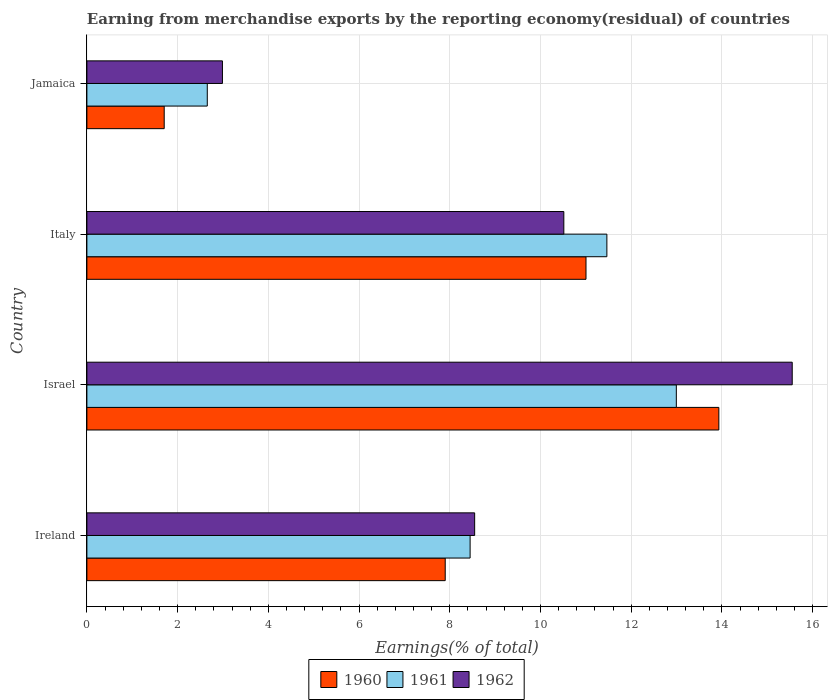How many groups of bars are there?
Offer a very short reply. 4. Are the number of bars on each tick of the Y-axis equal?
Offer a very short reply. Yes. How many bars are there on the 1st tick from the top?
Offer a very short reply. 3. What is the label of the 2nd group of bars from the top?
Your answer should be compact. Italy. What is the percentage of amount earned from merchandise exports in 1960 in Jamaica?
Offer a terse response. 1.7. Across all countries, what is the maximum percentage of amount earned from merchandise exports in 1960?
Your answer should be very brief. 13.93. Across all countries, what is the minimum percentage of amount earned from merchandise exports in 1962?
Ensure brevity in your answer.  2.99. In which country was the percentage of amount earned from merchandise exports in 1962 maximum?
Ensure brevity in your answer.  Israel. In which country was the percentage of amount earned from merchandise exports in 1962 minimum?
Your answer should be compact. Jamaica. What is the total percentage of amount earned from merchandise exports in 1960 in the graph?
Provide a succinct answer. 34.54. What is the difference between the percentage of amount earned from merchandise exports in 1960 in Ireland and that in Jamaica?
Offer a terse response. 6.2. What is the difference between the percentage of amount earned from merchandise exports in 1960 in Israel and the percentage of amount earned from merchandise exports in 1961 in Italy?
Ensure brevity in your answer.  2.47. What is the average percentage of amount earned from merchandise exports in 1962 per country?
Provide a short and direct response. 9.4. What is the difference between the percentage of amount earned from merchandise exports in 1962 and percentage of amount earned from merchandise exports in 1961 in Ireland?
Provide a succinct answer. 0.1. In how many countries, is the percentage of amount earned from merchandise exports in 1962 greater than 11.2 %?
Your response must be concise. 1. What is the ratio of the percentage of amount earned from merchandise exports in 1962 in Ireland to that in Israel?
Ensure brevity in your answer.  0.55. Is the percentage of amount earned from merchandise exports in 1961 in Ireland less than that in Italy?
Provide a succinct answer. Yes. Is the difference between the percentage of amount earned from merchandise exports in 1962 in Ireland and Italy greater than the difference between the percentage of amount earned from merchandise exports in 1961 in Ireland and Italy?
Offer a terse response. Yes. What is the difference between the highest and the second highest percentage of amount earned from merchandise exports in 1962?
Provide a short and direct response. 5.04. What is the difference between the highest and the lowest percentage of amount earned from merchandise exports in 1961?
Keep it short and to the point. 10.34. What does the 1st bar from the bottom in Italy represents?
Make the answer very short. 1960. Is it the case that in every country, the sum of the percentage of amount earned from merchandise exports in 1960 and percentage of amount earned from merchandise exports in 1961 is greater than the percentage of amount earned from merchandise exports in 1962?
Your response must be concise. Yes. How many bars are there?
Ensure brevity in your answer.  12. Are the values on the major ticks of X-axis written in scientific E-notation?
Make the answer very short. No. Does the graph contain any zero values?
Provide a short and direct response. No. Does the graph contain grids?
Your response must be concise. Yes. Where does the legend appear in the graph?
Give a very brief answer. Bottom center. How are the legend labels stacked?
Make the answer very short. Horizontal. What is the title of the graph?
Offer a terse response. Earning from merchandise exports by the reporting economy(residual) of countries. Does "2010" appear as one of the legend labels in the graph?
Keep it short and to the point. No. What is the label or title of the X-axis?
Your answer should be very brief. Earnings(% of total). What is the Earnings(% of total) of 1960 in Ireland?
Keep it short and to the point. 7.9. What is the Earnings(% of total) in 1961 in Ireland?
Keep it short and to the point. 8.45. What is the Earnings(% of total) of 1962 in Ireland?
Make the answer very short. 8.55. What is the Earnings(% of total) in 1960 in Israel?
Offer a very short reply. 13.93. What is the Earnings(% of total) in 1961 in Israel?
Ensure brevity in your answer.  13. What is the Earnings(% of total) in 1962 in Israel?
Ensure brevity in your answer.  15.55. What is the Earnings(% of total) in 1960 in Italy?
Your answer should be very brief. 11. What is the Earnings(% of total) in 1961 in Italy?
Provide a short and direct response. 11.46. What is the Earnings(% of total) of 1962 in Italy?
Give a very brief answer. 10.52. What is the Earnings(% of total) of 1960 in Jamaica?
Provide a short and direct response. 1.7. What is the Earnings(% of total) of 1961 in Jamaica?
Give a very brief answer. 2.65. What is the Earnings(% of total) of 1962 in Jamaica?
Ensure brevity in your answer.  2.99. Across all countries, what is the maximum Earnings(% of total) of 1960?
Your answer should be compact. 13.93. Across all countries, what is the maximum Earnings(% of total) of 1961?
Ensure brevity in your answer.  13. Across all countries, what is the maximum Earnings(% of total) in 1962?
Your answer should be very brief. 15.55. Across all countries, what is the minimum Earnings(% of total) of 1960?
Provide a short and direct response. 1.7. Across all countries, what is the minimum Earnings(% of total) of 1961?
Your answer should be very brief. 2.65. Across all countries, what is the minimum Earnings(% of total) in 1962?
Your response must be concise. 2.99. What is the total Earnings(% of total) of 1960 in the graph?
Provide a short and direct response. 34.54. What is the total Earnings(% of total) of 1961 in the graph?
Offer a very short reply. 35.56. What is the total Earnings(% of total) in 1962 in the graph?
Offer a terse response. 37.6. What is the difference between the Earnings(% of total) of 1960 in Ireland and that in Israel?
Your response must be concise. -6.03. What is the difference between the Earnings(% of total) in 1961 in Ireland and that in Israel?
Your response must be concise. -4.55. What is the difference between the Earnings(% of total) of 1962 in Ireland and that in Israel?
Provide a short and direct response. -7. What is the difference between the Earnings(% of total) of 1960 in Ireland and that in Italy?
Offer a terse response. -3.1. What is the difference between the Earnings(% of total) of 1961 in Ireland and that in Italy?
Make the answer very short. -3.02. What is the difference between the Earnings(% of total) in 1962 in Ireland and that in Italy?
Offer a terse response. -1.97. What is the difference between the Earnings(% of total) in 1960 in Ireland and that in Jamaica?
Your answer should be compact. 6.2. What is the difference between the Earnings(% of total) in 1961 in Ireland and that in Jamaica?
Ensure brevity in your answer.  5.79. What is the difference between the Earnings(% of total) of 1962 in Ireland and that in Jamaica?
Offer a terse response. 5.56. What is the difference between the Earnings(% of total) of 1960 in Israel and that in Italy?
Keep it short and to the point. 2.93. What is the difference between the Earnings(% of total) of 1961 in Israel and that in Italy?
Ensure brevity in your answer.  1.53. What is the difference between the Earnings(% of total) of 1962 in Israel and that in Italy?
Your response must be concise. 5.04. What is the difference between the Earnings(% of total) in 1960 in Israel and that in Jamaica?
Provide a succinct answer. 12.23. What is the difference between the Earnings(% of total) in 1961 in Israel and that in Jamaica?
Give a very brief answer. 10.34. What is the difference between the Earnings(% of total) in 1962 in Israel and that in Jamaica?
Your answer should be very brief. 12.56. What is the difference between the Earnings(% of total) in 1960 in Italy and that in Jamaica?
Keep it short and to the point. 9.3. What is the difference between the Earnings(% of total) of 1961 in Italy and that in Jamaica?
Provide a short and direct response. 8.81. What is the difference between the Earnings(% of total) in 1962 in Italy and that in Jamaica?
Keep it short and to the point. 7.53. What is the difference between the Earnings(% of total) of 1960 in Ireland and the Earnings(% of total) of 1961 in Israel?
Your answer should be very brief. -5.1. What is the difference between the Earnings(% of total) of 1960 in Ireland and the Earnings(% of total) of 1962 in Israel?
Keep it short and to the point. -7.65. What is the difference between the Earnings(% of total) in 1961 in Ireland and the Earnings(% of total) in 1962 in Israel?
Provide a short and direct response. -7.1. What is the difference between the Earnings(% of total) in 1960 in Ireland and the Earnings(% of total) in 1961 in Italy?
Your answer should be very brief. -3.56. What is the difference between the Earnings(% of total) in 1960 in Ireland and the Earnings(% of total) in 1962 in Italy?
Ensure brevity in your answer.  -2.61. What is the difference between the Earnings(% of total) of 1961 in Ireland and the Earnings(% of total) of 1962 in Italy?
Offer a very short reply. -2.07. What is the difference between the Earnings(% of total) of 1960 in Ireland and the Earnings(% of total) of 1961 in Jamaica?
Your response must be concise. 5.25. What is the difference between the Earnings(% of total) in 1960 in Ireland and the Earnings(% of total) in 1962 in Jamaica?
Your answer should be very brief. 4.91. What is the difference between the Earnings(% of total) in 1961 in Ireland and the Earnings(% of total) in 1962 in Jamaica?
Your answer should be very brief. 5.46. What is the difference between the Earnings(% of total) in 1960 in Israel and the Earnings(% of total) in 1961 in Italy?
Provide a short and direct response. 2.47. What is the difference between the Earnings(% of total) in 1960 in Israel and the Earnings(% of total) in 1962 in Italy?
Offer a terse response. 3.42. What is the difference between the Earnings(% of total) in 1961 in Israel and the Earnings(% of total) in 1962 in Italy?
Your answer should be compact. 2.48. What is the difference between the Earnings(% of total) of 1960 in Israel and the Earnings(% of total) of 1961 in Jamaica?
Your answer should be very brief. 11.28. What is the difference between the Earnings(% of total) of 1960 in Israel and the Earnings(% of total) of 1962 in Jamaica?
Give a very brief answer. 10.94. What is the difference between the Earnings(% of total) in 1961 in Israel and the Earnings(% of total) in 1962 in Jamaica?
Provide a short and direct response. 10.01. What is the difference between the Earnings(% of total) in 1960 in Italy and the Earnings(% of total) in 1961 in Jamaica?
Keep it short and to the point. 8.35. What is the difference between the Earnings(% of total) in 1960 in Italy and the Earnings(% of total) in 1962 in Jamaica?
Ensure brevity in your answer.  8.02. What is the difference between the Earnings(% of total) in 1961 in Italy and the Earnings(% of total) in 1962 in Jamaica?
Offer a terse response. 8.48. What is the average Earnings(% of total) in 1960 per country?
Ensure brevity in your answer.  8.64. What is the average Earnings(% of total) in 1961 per country?
Give a very brief answer. 8.89. What is the average Earnings(% of total) of 1962 per country?
Provide a short and direct response. 9.4. What is the difference between the Earnings(% of total) of 1960 and Earnings(% of total) of 1961 in Ireland?
Give a very brief answer. -0.55. What is the difference between the Earnings(% of total) in 1960 and Earnings(% of total) in 1962 in Ireland?
Your answer should be very brief. -0.65. What is the difference between the Earnings(% of total) of 1961 and Earnings(% of total) of 1962 in Ireland?
Provide a succinct answer. -0.1. What is the difference between the Earnings(% of total) in 1960 and Earnings(% of total) in 1961 in Israel?
Make the answer very short. 0.94. What is the difference between the Earnings(% of total) of 1960 and Earnings(% of total) of 1962 in Israel?
Your answer should be very brief. -1.62. What is the difference between the Earnings(% of total) in 1961 and Earnings(% of total) in 1962 in Israel?
Offer a very short reply. -2.56. What is the difference between the Earnings(% of total) of 1960 and Earnings(% of total) of 1961 in Italy?
Keep it short and to the point. -0.46. What is the difference between the Earnings(% of total) of 1960 and Earnings(% of total) of 1962 in Italy?
Make the answer very short. 0.49. What is the difference between the Earnings(% of total) in 1961 and Earnings(% of total) in 1962 in Italy?
Your response must be concise. 0.95. What is the difference between the Earnings(% of total) in 1960 and Earnings(% of total) in 1961 in Jamaica?
Give a very brief answer. -0.95. What is the difference between the Earnings(% of total) of 1960 and Earnings(% of total) of 1962 in Jamaica?
Offer a terse response. -1.28. What is the difference between the Earnings(% of total) of 1961 and Earnings(% of total) of 1962 in Jamaica?
Provide a short and direct response. -0.33. What is the ratio of the Earnings(% of total) of 1960 in Ireland to that in Israel?
Offer a terse response. 0.57. What is the ratio of the Earnings(% of total) in 1961 in Ireland to that in Israel?
Ensure brevity in your answer.  0.65. What is the ratio of the Earnings(% of total) of 1962 in Ireland to that in Israel?
Provide a short and direct response. 0.55. What is the ratio of the Earnings(% of total) in 1960 in Ireland to that in Italy?
Provide a short and direct response. 0.72. What is the ratio of the Earnings(% of total) of 1961 in Ireland to that in Italy?
Make the answer very short. 0.74. What is the ratio of the Earnings(% of total) of 1962 in Ireland to that in Italy?
Your response must be concise. 0.81. What is the ratio of the Earnings(% of total) in 1960 in Ireland to that in Jamaica?
Your answer should be compact. 4.63. What is the ratio of the Earnings(% of total) in 1961 in Ireland to that in Jamaica?
Offer a very short reply. 3.18. What is the ratio of the Earnings(% of total) of 1962 in Ireland to that in Jamaica?
Your answer should be very brief. 2.86. What is the ratio of the Earnings(% of total) of 1960 in Israel to that in Italy?
Make the answer very short. 1.27. What is the ratio of the Earnings(% of total) in 1961 in Israel to that in Italy?
Keep it short and to the point. 1.13. What is the ratio of the Earnings(% of total) of 1962 in Israel to that in Italy?
Your response must be concise. 1.48. What is the ratio of the Earnings(% of total) in 1960 in Israel to that in Jamaica?
Provide a succinct answer. 8.17. What is the ratio of the Earnings(% of total) of 1961 in Israel to that in Jamaica?
Make the answer very short. 4.9. What is the ratio of the Earnings(% of total) of 1962 in Israel to that in Jamaica?
Your answer should be compact. 5.2. What is the ratio of the Earnings(% of total) in 1960 in Italy to that in Jamaica?
Your answer should be very brief. 6.46. What is the ratio of the Earnings(% of total) in 1961 in Italy to that in Jamaica?
Make the answer very short. 4.32. What is the ratio of the Earnings(% of total) of 1962 in Italy to that in Jamaica?
Keep it short and to the point. 3.52. What is the difference between the highest and the second highest Earnings(% of total) in 1960?
Your answer should be very brief. 2.93. What is the difference between the highest and the second highest Earnings(% of total) of 1961?
Offer a terse response. 1.53. What is the difference between the highest and the second highest Earnings(% of total) of 1962?
Provide a succinct answer. 5.04. What is the difference between the highest and the lowest Earnings(% of total) in 1960?
Provide a succinct answer. 12.23. What is the difference between the highest and the lowest Earnings(% of total) of 1961?
Offer a very short reply. 10.34. What is the difference between the highest and the lowest Earnings(% of total) of 1962?
Offer a very short reply. 12.56. 